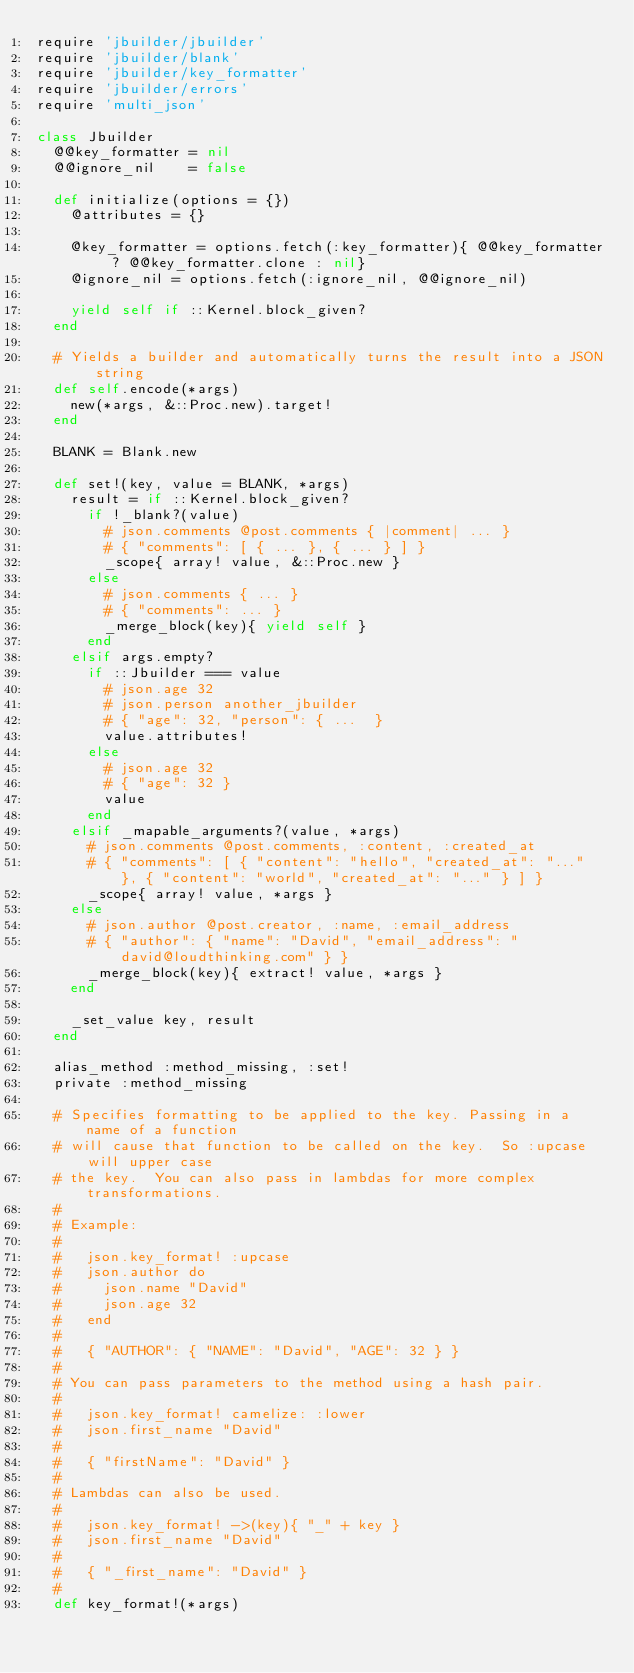<code> <loc_0><loc_0><loc_500><loc_500><_Ruby_>require 'jbuilder/jbuilder'
require 'jbuilder/blank'
require 'jbuilder/key_formatter'
require 'jbuilder/errors'
require 'multi_json'

class Jbuilder
  @@key_formatter = nil
  @@ignore_nil    = false

  def initialize(options = {})
    @attributes = {}

    @key_formatter = options.fetch(:key_formatter){ @@key_formatter ? @@key_formatter.clone : nil}
    @ignore_nil = options.fetch(:ignore_nil, @@ignore_nil)

    yield self if ::Kernel.block_given?
  end

  # Yields a builder and automatically turns the result into a JSON string
  def self.encode(*args)
    new(*args, &::Proc.new).target!
  end

  BLANK = Blank.new

  def set!(key, value = BLANK, *args)
    result = if ::Kernel.block_given?
      if !_blank?(value)
        # json.comments @post.comments { |comment| ... }
        # { "comments": [ { ... }, { ... } ] }
        _scope{ array! value, &::Proc.new }
      else
        # json.comments { ... }
        # { "comments": ... }
        _merge_block(key){ yield self }
      end
    elsif args.empty?
      if ::Jbuilder === value
        # json.age 32
        # json.person another_jbuilder
        # { "age": 32, "person": { ...  }
        value.attributes!
      else
        # json.age 32
        # { "age": 32 }
        value
      end
    elsif _mapable_arguments?(value, *args)
      # json.comments @post.comments, :content, :created_at
      # { "comments": [ { "content": "hello", "created_at": "..." }, { "content": "world", "created_at": "..." } ] }
      _scope{ array! value, *args }
    else
      # json.author @post.creator, :name, :email_address
      # { "author": { "name": "David", "email_address": "david@loudthinking.com" } }
      _merge_block(key){ extract! value, *args }
    end

    _set_value key, result
  end

  alias_method :method_missing, :set!
  private :method_missing

  # Specifies formatting to be applied to the key. Passing in a name of a function
  # will cause that function to be called on the key.  So :upcase will upper case
  # the key.  You can also pass in lambdas for more complex transformations.
  #
  # Example:
  #
  #   json.key_format! :upcase
  #   json.author do
  #     json.name "David"
  #     json.age 32
  #   end
  #
  #   { "AUTHOR": { "NAME": "David", "AGE": 32 } }
  #
  # You can pass parameters to the method using a hash pair.
  #
  #   json.key_format! camelize: :lower
  #   json.first_name "David"
  #
  #   { "firstName": "David" }
  #
  # Lambdas can also be used.
  #
  #   json.key_format! ->(key){ "_" + key }
  #   json.first_name "David"
  #
  #   { "_first_name": "David" }
  #
  def key_format!(*args)</code> 